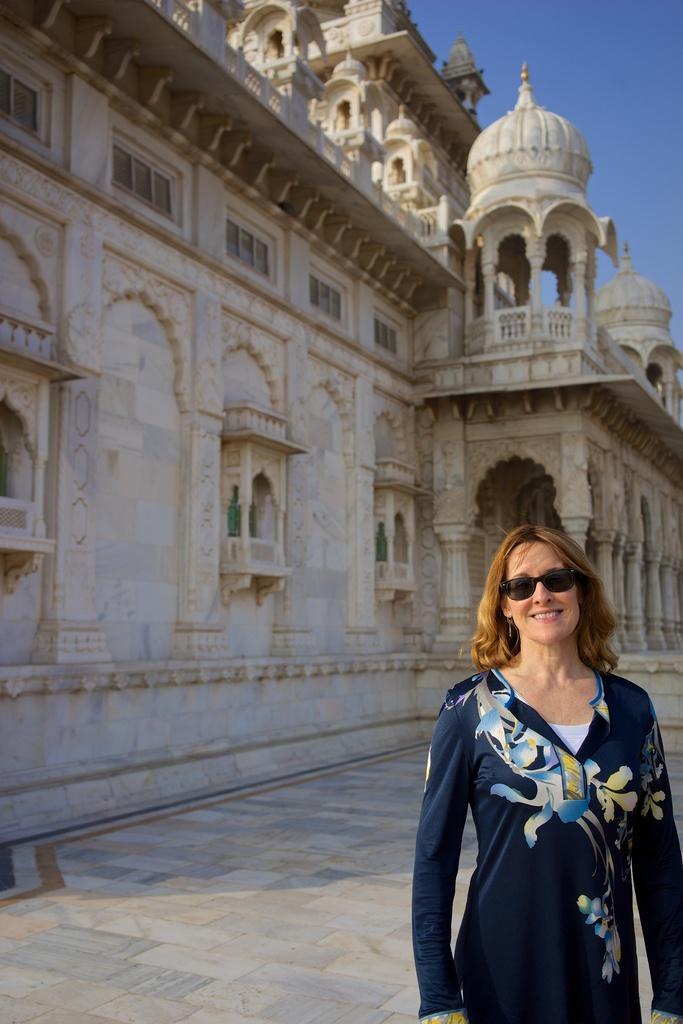Can you describe this image briefly? In this picture we can see a woman standing on the floor, side we can see the building. 